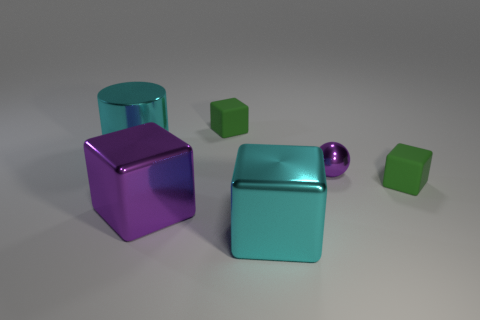Add 3 big cyan blocks. How many objects exist? 9 Subtract all spheres. How many objects are left? 5 Add 3 tiny blue shiny objects. How many tiny blue shiny objects exist? 3 Subtract 0 brown spheres. How many objects are left? 6 Subtract all large purple metallic cubes. Subtract all large purple cubes. How many objects are left? 4 Add 3 shiny blocks. How many shiny blocks are left? 5 